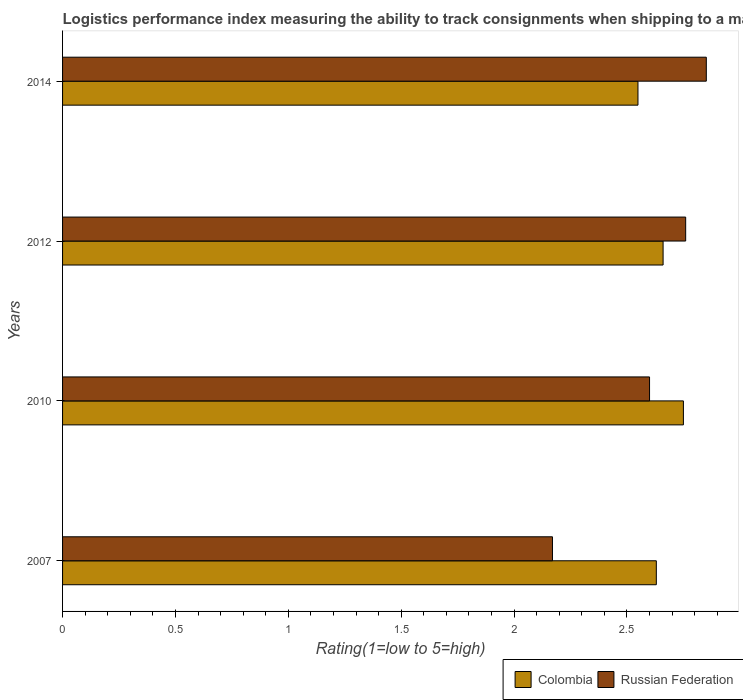How many groups of bars are there?
Your answer should be compact. 4. Are the number of bars per tick equal to the number of legend labels?
Offer a very short reply. Yes. How many bars are there on the 2nd tick from the top?
Provide a short and direct response. 2. What is the label of the 3rd group of bars from the top?
Make the answer very short. 2010. In how many cases, is the number of bars for a given year not equal to the number of legend labels?
Your response must be concise. 0. What is the Logistic performance index in Colombia in 2012?
Offer a terse response. 2.66. Across all years, what is the maximum Logistic performance index in Russian Federation?
Your answer should be compact. 2.85. Across all years, what is the minimum Logistic performance index in Colombia?
Give a very brief answer. 2.55. What is the total Logistic performance index in Colombia in the graph?
Offer a terse response. 10.59. What is the difference between the Logistic performance index in Colombia in 2007 and that in 2014?
Ensure brevity in your answer.  0.08. What is the difference between the Logistic performance index in Colombia in 2014 and the Logistic performance index in Russian Federation in 2007?
Your answer should be very brief. 0.38. What is the average Logistic performance index in Russian Federation per year?
Ensure brevity in your answer.  2.6. In the year 2014, what is the difference between the Logistic performance index in Colombia and Logistic performance index in Russian Federation?
Your response must be concise. -0.3. What is the ratio of the Logistic performance index in Russian Federation in 2007 to that in 2012?
Ensure brevity in your answer.  0.79. What is the difference between the highest and the second highest Logistic performance index in Russian Federation?
Your answer should be compact. 0.09. What is the difference between the highest and the lowest Logistic performance index in Russian Federation?
Offer a terse response. 0.68. Is the sum of the Logistic performance index in Russian Federation in 2010 and 2014 greater than the maximum Logistic performance index in Colombia across all years?
Ensure brevity in your answer.  Yes. What does the 1st bar from the bottom in 2014 represents?
Provide a succinct answer. Colombia. How many bars are there?
Offer a terse response. 8. Are all the bars in the graph horizontal?
Ensure brevity in your answer.  Yes. How many years are there in the graph?
Ensure brevity in your answer.  4. How many legend labels are there?
Offer a terse response. 2. How are the legend labels stacked?
Your answer should be compact. Horizontal. What is the title of the graph?
Give a very brief answer. Logistics performance index measuring the ability to track consignments when shipping to a market. What is the label or title of the X-axis?
Provide a short and direct response. Rating(1=low to 5=high). What is the Rating(1=low to 5=high) of Colombia in 2007?
Your answer should be compact. 2.63. What is the Rating(1=low to 5=high) of Russian Federation in 2007?
Provide a succinct answer. 2.17. What is the Rating(1=low to 5=high) in Colombia in 2010?
Offer a terse response. 2.75. What is the Rating(1=low to 5=high) of Russian Federation in 2010?
Provide a succinct answer. 2.6. What is the Rating(1=low to 5=high) in Colombia in 2012?
Provide a short and direct response. 2.66. What is the Rating(1=low to 5=high) in Russian Federation in 2012?
Offer a very short reply. 2.76. What is the Rating(1=low to 5=high) of Colombia in 2014?
Your answer should be compact. 2.55. What is the Rating(1=low to 5=high) in Russian Federation in 2014?
Offer a terse response. 2.85. Across all years, what is the maximum Rating(1=low to 5=high) of Colombia?
Ensure brevity in your answer.  2.75. Across all years, what is the maximum Rating(1=low to 5=high) of Russian Federation?
Offer a very short reply. 2.85. Across all years, what is the minimum Rating(1=low to 5=high) in Colombia?
Your answer should be compact. 2.55. Across all years, what is the minimum Rating(1=low to 5=high) in Russian Federation?
Your answer should be compact. 2.17. What is the total Rating(1=low to 5=high) of Colombia in the graph?
Give a very brief answer. 10.59. What is the total Rating(1=low to 5=high) of Russian Federation in the graph?
Your answer should be very brief. 10.38. What is the difference between the Rating(1=low to 5=high) of Colombia in 2007 and that in 2010?
Provide a short and direct response. -0.12. What is the difference between the Rating(1=low to 5=high) in Russian Federation in 2007 and that in 2010?
Ensure brevity in your answer.  -0.43. What is the difference between the Rating(1=low to 5=high) of Colombia in 2007 and that in 2012?
Your response must be concise. -0.03. What is the difference between the Rating(1=low to 5=high) in Russian Federation in 2007 and that in 2012?
Give a very brief answer. -0.59. What is the difference between the Rating(1=low to 5=high) in Colombia in 2007 and that in 2014?
Ensure brevity in your answer.  0.08. What is the difference between the Rating(1=low to 5=high) in Russian Federation in 2007 and that in 2014?
Your answer should be compact. -0.68. What is the difference between the Rating(1=low to 5=high) in Colombia in 2010 and that in 2012?
Your answer should be very brief. 0.09. What is the difference between the Rating(1=low to 5=high) of Russian Federation in 2010 and that in 2012?
Make the answer very short. -0.16. What is the difference between the Rating(1=low to 5=high) of Colombia in 2010 and that in 2014?
Make the answer very short. 0.2. What is the difference between the Rating(1=low to 5=high) in Russian Federation in 2010 and that in 2014?
Ensure brevity in your answer.  -0.25. What is the difference between the Rating(1=low to 5=high) of Colombia in 2012 and that in 2014?
Your response must be concise. 0.11. What is the difference between the Rating(1=low to 5=high) of Russian Federation in 2012 and that in 2014?
Your answer should be very brief. -0.09. What is the difference between the Rating(1=low to 5=high) of Colombia in 2007 and the Rating(1=low to 5=high) of Russian Federation in 2012?
Your answer should be compact. -0.13. What is the difference between the Rating(1=low to 5=high) of Colombia in 2007 and the Rating(1=low to 5=high) of Russian Federation in 2014?
Ensure brevity in your answer.  -0.22. What is the difference between the Rating(1=low to 5=high) in Colombia in 2010 and the Rating(1=low to 5=high) in Russian Federation in 2012?
Your answer should be compact. -0.01. What is the difference between the Rating(1=low to 5=high) in Colombia in 2010 and the Rating(1=low to 5=high) in Russian Federation in 2014?
Make the answer very short. -0.1. What is the difference between the Rating(1=low to 5=high) in Colombia in 2012 and the Rating(1=low to 5=high) in Russian Federation in 2014?
Give a very brief answer. -0.19. What is the average Rating(1=low to 5=high) in Colombia per year?
Offer a very short reply. 2.65. What is the average Rating(1=low to 5=high) of Russian Federation per year?
Keep it short and to the point. 2.6. In the year 2007, what is the difference between the Rating(1=low to 5=high) in Colombia and Rating(1=low to 5=high) in Russian Federation?
Provide a short and direct response. 0.46. In the year 2010, what is the difference between the Rating(1=low to 5=high) of Colombia and Rating(1=low to 5=high) of Russian Federation?
Your answer should be very brief. 0.15. In the year 2012, what is the difference between the Rating(1=low to 5=high) of Colombia and Rating(1=low to 5=high) of Russian Federation?
Ensure brevity in your answer.  -0.1. In the year 2014, what is the difference between the Rating(1=low to 5=high) in Colombia and Rating(1=low to 5=high) in Russian Federation?
Offer a very short reply. -0.3. What is the ratio of the Rating(1=low to 5=high) in Colombia in 2007 to that in 2010?
Give a very brief answer. 0.96. What is the ratio of the Rating(1=low to 5=high) of Russian Federation in 2007 to that in 2010?
Provide a succinct answer. 0.83. What is the ratio of the Rating(1=low to 5=high) in Colombia in 2007 to that in 2012?
Your response must be concise. 0.99. What is the ratio of the Rating(1=low to 5=high) in Russian Federation in 2007 to that in 2012?
Your answer should be very brief. 0.79. What is the ratio of the Rating(1=low to 5=high) in Colombia in 2007 to that in 2014?
Make the answer very short. 1.03. What is the ratio of the Rating(1=low to 5=high) in Russian Federation in 2007 to that in 2014?
Keep it short and to the point. 0.76. What is the ratio of the Rating(1=low to 5=high) of Colombia in 2010 to that in 2012?
Keep it short and to the point. 1.03. What is the ratio of the Rating(1=low to 5=high) in Russian Federation in 2010 to that in 2012?
Keep it short and to the point. 0.94. What is the ratio of the Rating(1=low to 5=high) of Colombia in 2010 to that in 2014?
Offer a very short reply. 1.08. What is the ratio of the Rating(1=low to 5=high) in Russian Federation in 2010 to that in 2014?
Offer a terse response. 0.91. What is the ratio of the Rating(1=low to 5=high) in Colombia in 2012 to that in 2014?
Provide a short and direct response. 1.04. What is the ratio of the Rating(1=low to 5=high) in Russian Federation in 2012 to that in 2014?
Your answer should be very brief. 0.97. What is the difference between the highest and the second highest Rating(1=low to 5=high) in Colombia?
Provide a short and direct response. 0.09. What is the difference between the highest and the second highest Rating(1=low to 5=high) of Russian Federation?
Offer a very short reply. 0.09. What is the difference between the highest and the lowest Rating(1=low to 5=high) in Colombia?
Make the answer very short. 0.2. What is the difference between the highest and the lowest Rating(1=low to 5=high) in Russian Federation?
Give a very brief answer. 0.68. 